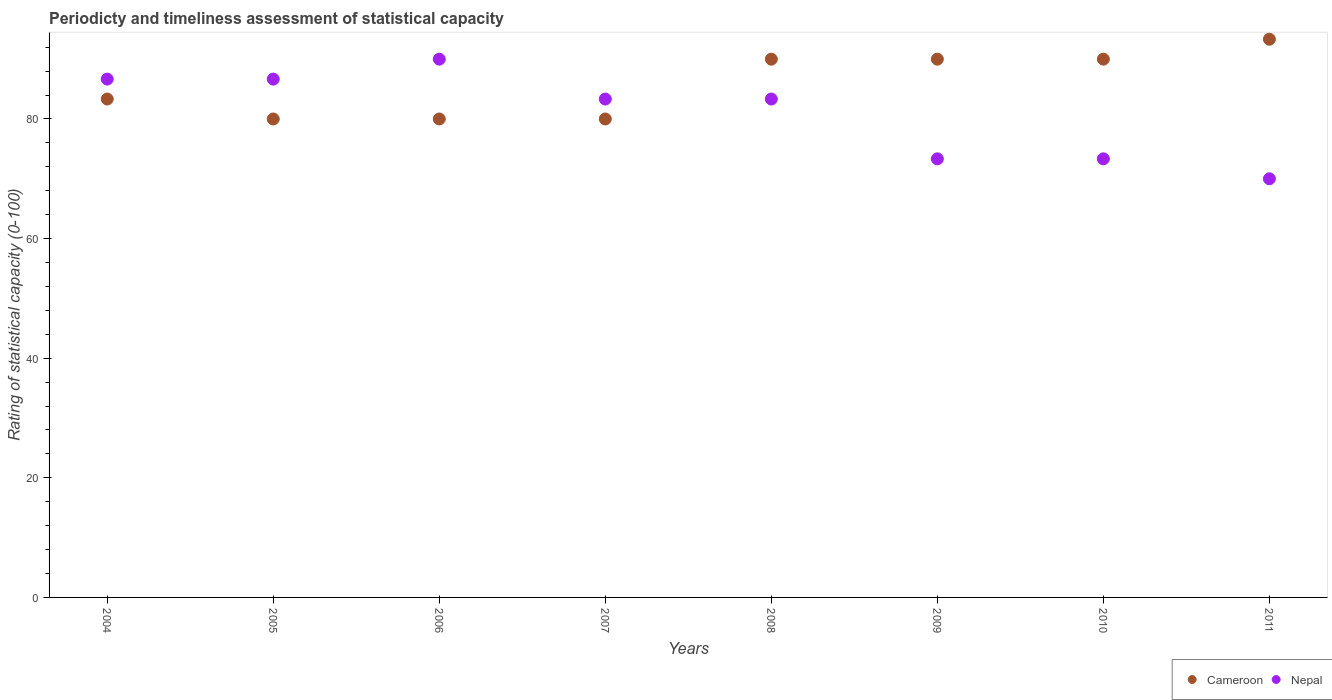How many different coloured dotlines are there?
Your answer should be compact. 2. Is the number of dotlines equal to the number of legend labels?
Your answer should be very brief. Yes. What is the rating of statistical capacity in Cameroon in 2011?
Provide a succinct answer. 93.33. In which year was the rating of statistical capacity in Cameroon minimum?
Give a very brief answer. 2005. What is the total rating of statistical capacity in Nepal in the graph?
Your response must be concise. 646.67. What is the difference between the rating of statistical capacity in Cameroon in 2007 and that in 2009?
Offer a terse response. -10. What is the average rating of statistical capacity in Nepal per year?
Keep it short and to the point. 80.83. In the year 2009, what is the difference between the rating of statistical capacity in Cameroon and rating of statistical capacity in Nepal?
Ensure brevity in your answer.  16.67. In how many years, is the rating of statistical capacity in Nepal greater than 12?
Provide a short and direct response. 8. What is the ratio of the rating of statistical capacity in Cameroon in 2005 to that in 2010?
Offer a terse response. 0.89. Is the difference between the rating of statistical capacity in Cameroon in 2007 and 2010 greater than the difference between the rating of statistical capacity in Nepal in 2007 and 2010?
Make the answer very short. No. What is the difference between the highest and the second highest rating of statistical capacity in Cameroon?
Your answer should be compact. 3.33. What is the difference between the highest and the lowest rating of statistical capacity in Cameroon?
Your answer should be very brief. 13.33. In how many years, is the rating of statistical capacity in Nepal greater than the average rating of statistical capacity in Nepal taken over all years?
Provide a short and direct response. 5. Does the rating of statistical capacity in Nepal monotonically increase over the years?
Provide a succinct answer. No. Is the rating of statistical capacity in Nepal strictly less than the rating of statistical capacity in Cameroon over the years?
Offer a terse response. No. How many dotlines are there?
Provide a short and direct response. 2. What is the difference between two consecutive major ticks on the Y-axis?
Offer a very short reply. 20. Are the values on the major ticks of Y-axis written in scientific E-notation?
Provide a short and direct response. No. Does the graph contain any zero values?
Offer a very short reply. No. Where does the legend appear in the graph?
Make the answer very short. Bottom right. How are the legend labels stacked?
Ensure brevity in your answer.  Horizontal. What is the title of the graph?
Keep it short and to the point. Periodicty and timeliness assessment of statistical capacity. What is the label or title of the X-axis?
Keep it short and to the point. Years. What is the label or title of the Y-axis?
Your answer should be compact. Rating of statistical capacity (0-100). What is the Rating of statistical capacity (0-100) of Cameroon in 2004?
Your answer should be compact. 83.33. What is the Rating of statistical capacity (0-100) in Nepal in 2004?
Provide a short and direct response. 86.67. What is the Rating of statistical capacity (0-100) of Cameroon in 2005?
Your response must be concise. 80. What is the Rating of statistical capacity (0-100) of Nepal in 2005?
Provide a short and direct response. 86.67. What is the Rating of statistical capacity (0-100) of Nepal in 2007?
Ensure brevity in your answer.  83.33. What is the Rating of statistical capacity (0-100) in Nepal in 2008?
Your response must be concise. 83.33. What is the Rating of statistical capacity (0-100) of Cameroon in 2009?
Offer a very short reply. 90. What is the Rating of statistical capacity (0-100) in Nepal in 2009?
Offer a very short reply. 73.33. What is the Rating of statistical capacity (0-100) of Cameroon in 2010?
Make the answer very short. 90. What is the Rating of statistical capacity (0-100) of Nepal in 2010?
Offer a terse response. 73.33. What is the Rating of statistical capacity (0-100) in Cameroon in 2011?
Give a very brief answer. 93.33. Across all years, what is the maximum Rating of statistical capacity (0-100) in Cameroon?
Provide a succinct answer. 93.33. What is the total Rating of statistical capacity (0-100) in Cameroon in the graph?
Your answer should be very brief. 686.67. What is the total Rating of statistical capacity (0-100) in Nepal in the graph?
Keep it short and to the point. 646.67. What is the difference between the Rating of statistical capacity (0-100) of Cameroon in 2004 and that in 2005?
Give a very brief answer. 3.33. What is the difference between the Rating of statistical capacity (0-100) in Nepal in 2004 and that in 2005?
Keep it short and to the point. 0. What is the difference between the Rating of statistical capacity (0-100) in Nepal in 2004 and that in 2006?
Keep it short and to the point. -3.33. What is the difference between the Rating of statistical capacity (0-100) of Cameroon in 2004 and that in 2008?
Provide a succinct answer. -6.67. What is the difference between the Rating of statistical capacity (0-100) in Cameroon in 2004 and that in 2009?
Your response must be concise. -6.67. What is the difference between the Rating of statistical capacity (0-100) in Nepal in 2004 and that in 2009?
Ensure brevity in your answer.  13.33. What is the difference between the Rating of statistical capacity (0-100) in Cameroon in 2004 and that in 2010?
Provide a short and direct response. -6.67. What is the difference between the Rating of statistical capacity (0-100) of Nepal in 2004 and that in 2010?
Provide a succinct answer. 13.33. What is the difference between the Rating of statistical capacity (0-100) of Cameroon in 2004 and that in 2011?
Your answer should be very brief. -10. What is the difference between the Rating of statistical capacity (0-100) of Nepal in 2004 and that in 2011?
Provide a succinct answer. 16.67. What is the difference between the Rating of statistical capacity (0-100) in Cameroon in 2005 and that in 2006?
Provide a succinct answer. 0. What is the difference between the Rating of statistical capacity (0-100) in Cameroon in 2005 and that in 2007?
Make the answer very short. 0. What is the difference between the Rating of statistical capacity (0-100) of Cameroon in 2005 and that in 2008?
Your response must be concise. -10. What is the difference between the Rating of statistical capacity (0-100) of Nepal in 2005 and that in 2008?
Keep it short and to the point. 3.33. What is the difference between the Rating of statistical capacity (0-100) of Nepal in 2005 and that in 2009?
Give a very brief answer. 13.33. What is the difference between the Rating of statistical capacity (0-100) of Cameroon in 2005 and that in 2010?
Ensure brevity in your answer.  -10. What is the difference between the Rating of statistical capacity (0-100) in Nepal in 2005 and that in 2010?
Make the answer very short. 13.33. What is the difference between the Rating of statistical capacity (0-100) in Cameroon in 2005 and that in 2011?
Give a very brief answer. -13.33. What is the difference between the Rating of statistical capacity (0-100) of Nepal in 2005 and that in 2011?
Give a very brief answer. 16.67. What is the difference between the Rating of statistical capacity (0-100) in Cameroon in 2006 and that in 2007?
Provide a short and direct response. 0. What is the difference between the Rating of statistical capacity (0-100) of Nepal in 2006 and that in 2007?
Offer a very short reply. 6.67. What is the difference between the Rating of statistical capacity (0-100) of Nepal in 2006 and that in 2009?
Ensure brevity in your answer.  16.67. What is the difference between the Rating of statistical capacity (0-100) in Nepal in 2006 and that in 2010?
Provide a short and direct response. 16.67. What is the difference between the Rating of statistical capacity (0-100) of Cameroon in 2006 and that in 2011?
Ensure brevity in your answer.  -13.33. What is the difference between the Rating of statistical capacity (0-100) of Nepal in 2006 and that in 2011?
Give a very brief answer. 20. What is the difference between the Rating of statistical capacity (0-100) of Nepal in 2007 and that in 2008?
Offer a very short reply. 0. What is the difference between the Rating of statistical capacity (0-100) of Cameroon in 2007 and that in 2009?
Give a very brief answer. -10. What is the difference between the Rating of statistical capacity (0-100) in Nepal in 2007 and that in 2009?
Make the answer very short. 10. What is the difference between the Rating of statistical capacity (0-100) of Cameroon in 2007 and that in 2011?
Provide a short and direct response. -13.33. What is the difference between the Rating of statistical capacity (0-100) in Nepal in 2007 and that in 2011?
Provide a succinct answer. 13.33. What is the difference between the Rating of statistical capacity (0-100) in Nepal in 2008 and that in 2009?
Your answer should be very brief. 10. What is the difference between the Rating of statistical capacity (0-100) of Cameroon in 2008 and that in 2010?
Give a very brief answer. 0. What is the difference between the Rating of statistical capacity (0-100) of Nepal in 2008 and that in 2010?
Provide a succinct answer. 10. What is the difference between the Rating of statistical capacity (0-100) of Cameroon in 2008 and that in 2011?
Provide a short and direct response. -3.33. What is the difference between the Rating of statistical capacity (0-100) of Nepal in 2008 and that in 2011?
Ensure brevity in your answer.  13.33. What is the difference between the Rating of statistical capacity (0-100) of Nepal in 2009 and that in 2010?
Your answer should be compact. 0. What is the difference between the Rating of statistical capacity (0-100) in Cameroon in 2009 and that in 2011?
Give a very brief answer. -3.33. What is the difference between the Rating of statistical capacity (0-100) of Nepal in 2009 and that in 2011?
Provide a succinct answer. 3.33. What is the difference between the Rating of statistical capacity (0-100) in Cameroon in 2010 and that in 2011?
Your response must be concise. -3.33. What is the difference between the Rating of statistical capacity (0-100) in Cameroon in 2004 and the Rating of statistical capacity (0-100) in Nepal in 2005?
Provide a succinct answer. -3.33. What is the difference between the Rating of statistical capacity (0-100) of Cameroon in 2004 and the Rating of statistical capacity (0-100) of Nepal in 2006?
Offer a terse response. -6.67. What is the difference between the Rating of statistical capacity (0-100) in Cameroon in 2004 and the Rating of statistical capacity (0-100) in Nepal in 2007?
Offer a terse response. 0. What is the difference between the Rating of statistical capacity (0-100) of Cameroon in 2004 and the Rating of statistical capacity (0-100) of Nepal in 2008?
Offer a terse response. 0. What is the difference between the Rating of statistical capacity (0-100) of Cameroon in 2004 and the Rating of statistical capacity (0-100) of Nepal in 2009?
Offer a terse response. 10. What is the difference between the Rating of statistical capacity (0-100) of Cameroon in 2004 and the Rating of statistical capacity (0-100) of Nepal in 2010?
Make the answer very short. 10. What is the difference between the Rating of statistical capacity (0-100) in Cameroon in 2004 and the Rating of statistical capacity (0-100) in Nepal in 2011?
Offer a very short reply. 13.33. What is the difference between the Rating of statistical capacity (0-100) in Cameroon in 2005 and the Rating of statistical capacity (0-100) in Nepal in 2006?
Your response must be concise. -10. What is the difference between the Rating of statistical capacity (0-100) of Cameroon in 2005 and the Rating of statistical capacity (0-100) of Nepal in 2008?
Provide a succinct answer. -3.33. What is the difference between the Rating of statistical capacity (0-100) of Cameroon in 2005 and the Rating of statistical capacity (0-100) of Nepal in 2009?
Offer a terse response. 6.67. What is the difference between the Rating of statistical capacity (0-100) in Cameroon in 2005 and the Rating of statistical capacity (0-100) in Nepal in 2010?
Offer a terse response. 6.67. What is the difference between the Rating of statistical capacity (0-100) in Cameroon in 2006 and the Rating of statistical capacity (0-100) in Nepal in 2007?
Offer a very short reply. -3.33. What is the difference between the Rating of statistical capacity (0-100) in Cameroon in 2006 and the Rating of statistical capacity (0-100) in Nepal in 2010?
Offer a very short reply. 6.67. What is the difference between the Rating of statistical capacity (0-100) in Cameroon in 2007 and the Rating of statistical capacity (0-100) in Nepal in 2008?
Provide a succinct answer. -3.33. What is the difference between the Rating of statistical capacity (0-100) of Cameroon in 2007 and the Rating of statistical capacity (0-100) of Nepal in 2009?
Your answer should be compact. 6.67. What is the difference between the Rating of statistical capacity (0-100) of Cameroon in 2008 and the Rating of statistical capacity (0-100) of Nepal in 2009?
Your answer should be compact. 16.67. What is the difference between the Rating of statistical capacity (0-100) of Cameroon in 2008 and the Rating of statistical capacity (0-100) of Nepal in 2010?
Offer a very short reply. 16.67. What is the difference between the Rating of statistical capacity (0-100) of Cameroon in 2009 and the Rating of statistical capacity (0-100) of Nepal in 2010?
Provide a succinct answer. 16.67. What is the average Rating of statistical capacity (0-100) of Cameroon per year?
Offer a terse response. 85.83. What is the average Rating of statistical capacity (0-100) in Nepal per year?
Offer a very short reply. 80.83. In the year 2004, what is the difference between the Rating of statistical capacity (0-100) of Cameroon and Rating of statistical capacity (0-100) of Nepal?
Provide a succinct answer. -3.33. In the year 2005, what is the difference between the Rating of statistical capacity (0-100) of Cameroon and Rating of statistical capacity (0-100) of Nepal?
Make the answer very short. -6.67. In the year 2007, what is the difference between the Rating of statistical capacity (0-100) in Cameroon and Rating of statistical capacity (0-100) in Nepal?
Your response must be concise. -3.33. In the year 2009, what is the difference between the Rating of statistical capacity (0-100) in Cameroon and Rating of statistical capacity (0-100) in Nepal?
Ensure brevity in your answer.  16.67. In the year 2010, what is the difference between the Rating of statistical capacity (0-100) in Cameroon and Rating of statistical capacity (0-100) in Nepal?
Give a very brief answer. 16.67. In the year 2011, what is the difference between the Rating of statistical capacity (0-100) in Cameroon and Rating of statistical capacity (0-100) in Nepal?
Make the answer very short. 23.33. What is the ratio of the Rating of statistical capacity (0-100) in Cameroon in 2004 to that in 2005?
Provide a short and direct response. 1.04. What is the ratio of the Rating of statistical capacity (0-100) in Nepal in 2004 to that in 2005?
Make the answer very short. 1. What is the ratio of the Rating of statistical capacity (0-100) in Cameroon in 2004 to that in 2006?
Ensure brevity in your answer.  1.04. What is the ratio of the Rating of statistical capacity (0-100) in Cameroon in 2004 to that in 2007?
Provide a succinct answer. 1.04. What is the ratio of the Rating of statistical capacity (0-100) of Cameroon in 2004 to that in 2008?
Give a very brief answer. 0.93. What is the ratio of the Rating of statistical capacity (0-100) in Nepal in 2004 to that in 2008?
Ensure brevity in your answer.  1.04. What is the ratio of the Rating of statistical capacity (0-100) in Cameroon in 2004 to that in 2009?
Provide a short and direct response. 0.93. What is the ratio of the Rating of statistical capacity (0-100) of Nepal in 2004 to that in 2009?
Give a very brief answer. 1.18. What is the ratio of the Rating of statistical capacity (0-100) in Cameroon in 2004 to that in 2010?
Give a very brief answer. 0.93. What is the ratio of the Rating of statistical capacity (0-100) of Nepal in 2004 to that in 2010?
Provide a succinct answer. 1.18. What is the ratio of the Rating of statistical capacity (0-100) in Cameroon in 2004 to that in 2011?
Your response must be concise. 0.89. What is the ratio of the Rating of statistical capacity (0-100) in Nepal in 2004 to that in 2011?
Give a very brief answer. 1.24. What is the ratio of the Rating of statistical capacity (0-100) in Nepal in 2005 to that in 2009?
Your answer should be very brief. 1.18. What is the ratio of the Rating of statistical capacity (0-100) in Cameroon in 2005 to that in 2010?
Your answer should be very brief. 0.89. What is the ratio of the Rating of statistical capacity (0-100) in Nepal in 2005 to that in 2010?
Your response must be concise. 1.18. What is the ratio of the Rating of statistical capacity (0-100) in Cameroon in 2005 to that in 2011?
Your response must be concise. 0.86. What is the ratio of the Rating of statistical capacity (0-100) in Nepal in 2005 to that in 2011?
Your answer should be compact. 1.24. What is the ratio of the Rating of statistical capacity (0-100) in Cameroon in 2006 to that in 2007?
Give a very brief answer. 1. What is the ratio of the Rating of statistical capacity (0-100) of Nepal in 2006 to that in 2007?
Keep it short and to the point. 1.08. What is the ratio of the Rating of statistical capacity (0-100) of Nepal in 2006 to that in 2009?
Give a very brief answer. 1.23. What is the ratio of the Rating of statistical capacity (0-100) of Cameroon in 2006 to that in 2010?
Provide a short and direct response. 0.89. What is the ratio of the Rating of statistical capacity (0-100) in Nepal in 2006 to that in 2010?
Your response must be concise. 1.23. What is the ratio of the Rating of statistical capacity (0-100) in Cameroon in 2006 to that in 2011?
Your answer should be very brief. 0.86. What is the ratio of the Rating of statistical capacity (0-100) in Cameroon in 2007 to that in 2009?
Offer a very short reply. 0.89. What is the ratio of the Rating of statistical capacity (0-100) in Nepal in 2007 to that in 2009?
Your answer should be compact. 1.14. What is the ratio of the Rating of statistical capacity (0-100) of Cameroon in 2007 to that in 2010?
Your response must be concise. 0.89. What is the ratio of the Rating of statistical capacity (0-100) in Nepal in 2007 to that in 2010?
Provide a short and direct response. 1.14. What is the ratio of the Rating of statistical capacity (0-100) of Nepal in 2007 to that in 2011?
Offer a terse response. 1.19. What is the ratio of the Rating of statistical capacity (0-100) in Nepal in 2008 to that in 2009?
Your answer should be very brief. 1.14. What is the ratio of the Rating of statistical capacity (0-100) in Cameroon in 2008 to that in 2010?
Offer a very short reply. 1. What is the ratio of the Rating of statistical capacity (0-100) in Nepal in 2008 to that in 2010?
Your response must be concise. 1.14. What is the ratio of the Rating of statistical capacity (0-100) in Cameroon in 2008 to that in 2011?
Provide a succinct answer. 0.96. What is the ratio of the Rating of statistical capacity (0-100) in Nepal in 2008 to that in 2011?
Your answer should be compact. 1.19. What is the ratio of the Rating of statistical capacity (0-100) of Cameroon in 2009 to that in 2010?
Offer a terse response. 1. What is the ratio of the Rating of statistical capacity (0-100) of Nepal in 2009 to that in 2011?
Your answer should be very brief. 1.05. What is the ratio of the Rating of statistical capacity (0-100) of Cameroon in 2010 to that in 2011?
Ensure brevity in your answer.  0.96. What is the ratio of the Rating of statistical capacity (0-100) of Nepal in 2010 to that in 2011?
Offer a very short reply. 1.05. What is the difference between the highest and the lowest Rating of statistical capacity (0-100) of Cameroon?
Make the answer very short. 13.33. 